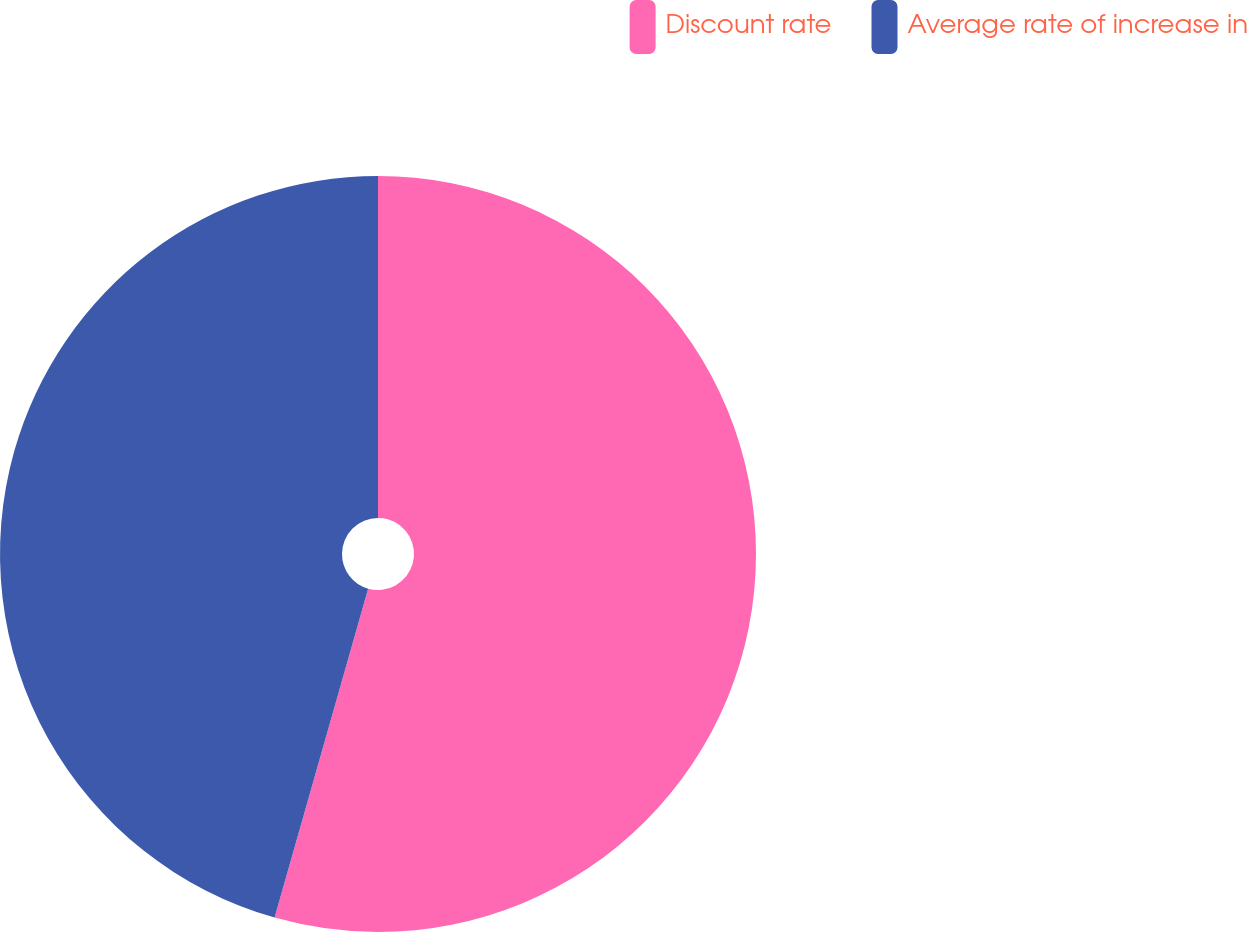<chart> <loc_0><loc_0><loc_500><loc_500><pie_chart><fcel>Discount rate<fcel>Average rate of increase in<nl><fcel>54.41%<fcel>45.59%<nl></chart> 